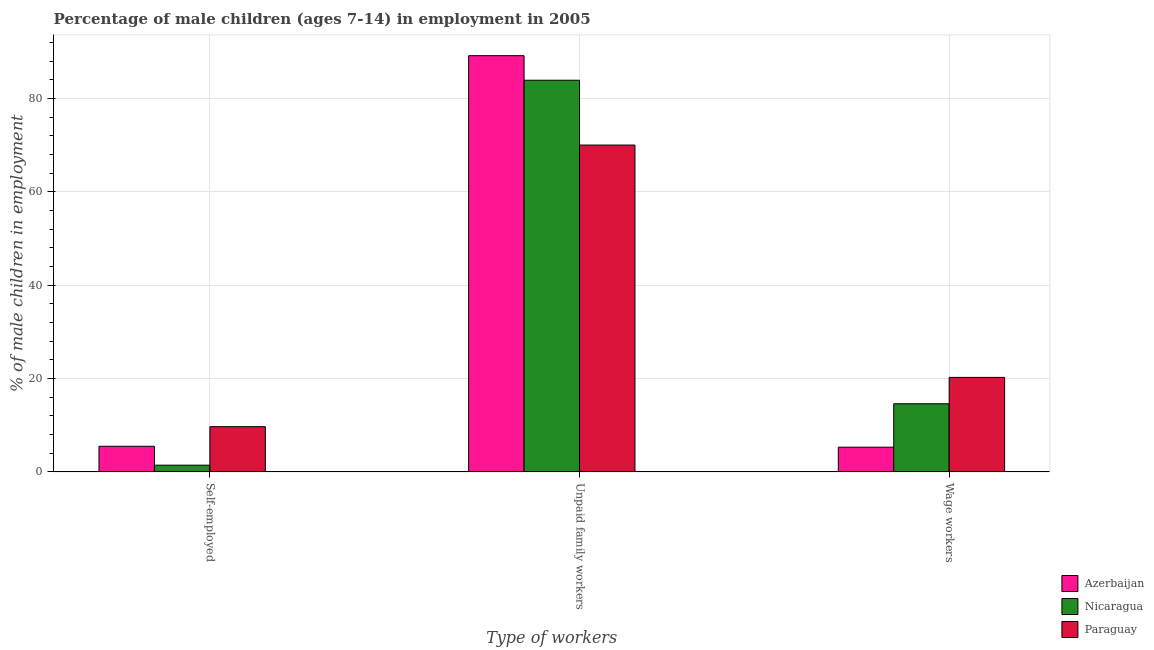How many different coloured bars are there?
Make the answer very short. 3. How many groups of bars are there?
Offer a terse response. 3. Are the number of bars on each tick of the X-axis equal?
Provide a short and direct response. Yes. How many bars are there on the 1st tick from the left?
Offer a very short reply. 3. How many bars are there on the 2nd tick from the right?
Keep it short and to the point. 3. What is the label of the 2nd group of bars from the left?
Ensure brevity in your answer.  Unpaid family workers. What is the percentage of self employed children in Nicaragua?
Provide a succinct answer. 1.45. Across all countries, what is the maximum percentage of children employed as wage workers?
Your answer should be very brief. 20.26. Across all countries, what is the minimum percentage of children employed as unpaid family workers?
Provide a succinct answer. 70.05. In which country was the percentage of children employed as unpaid family workers maximum?
Provide a succinct answer. Azerbaijan. In which country was the percentage of children employed as wage workers minimum?
Keep it short and to the point. Azerbaijan. What is the total percentage of children employed as wage workers in the graph?
Your answer should be compact. 40.17. What is the difference between the percentage of self employed children in Paraguay and that in Nicaragua?
Offer a very short reply. 8.25. What is the difference between the percentage of self employed children in Nicaragua and the percentage of children employed as wage workers in Paraguay?
Keep it short and to the point. -18.81. What is the average percentage of self employed children per country?
Ensure brevity in your answer.  5.55. What is the difference between the percentage of self employed children and percentage of children employed as unpaid family workers in Nicaragua?
Your answer should be very brief. -82.49. In how many countries, is the percentage of children employed as wage workers greater than 48 %?
Your answer should be compact. 0. What is the ratio of the percentage of self employed children in Nicaragua to that in Paraguay?
Provide a short and direct response. 0.15. Is the difference between the percentage of children employed as wage workers in Paraguay and Nicaragua greater than the difference between the percentage of children employed as unpaid family workers in Paraguay and Nicaragua?
Give a very brief answer. Yes. What is the difference between the highest and the second highest percentage of self employed children?
Provide a succinct answer. 4.2. What is the difference between the highest and the lowest percentage of self employed children?
Make the answer very short. 8.25. In how many countries, is the percentage of children employed as unpaid family workers greater than the average percentage of children employed as unpaid family workers taken over all countries?
Give a very brief answer. 2. Is the sum of the percentage of children employed as unpaid family workers in Nicaragua and Paraguay greater than the maximum percentage of children employed as wage workers across all countries?
Make the answer very short. Yes. What does the 2nd bar from the left in Unpaid family workers represents?
Offer a terse response. Nicaragua. What does the 1st bar from the right in Unpaid family workers represents?
Provide a short and direct response. Paraguay. Are all the bars in the graph horizontal?
Ensure brevity in your answer.  No. How many countries are there in the graph?
Ensure brevity in your answer.  3. Are the values on the major ticks of Y-axis written in scientific E-notation?
Your response must be concise. No. Does the graph contain any zero values?
Offer a terse response. No. Does the graph contain grids?
Give a very brief answer. Yes. How are the legend labels stacked?
Your answer should be very brief. Vertical. What is the title of the graph?
Provide a succinct answer. Percentage of male children (ages 7-14) in employment in 2005. What is the label or title of the X-axis?
Your answer should be compact. Type of workers. What is the label or title of the Y-axis?
Offer a very short reply. % of male children in employment. What is the % of male children in employment in Azerbaijan in Self-employed?
Your answer should be compact. 5.5. What is the % of male children in employment of Nicaragua in Self-employed?
Offer a terse response. 1.45. What is the % of male children in employment of Azerbaijan in Unpaid family workers?
Provide a short and direct response. 89.2. What is the % of male children in employment in Nicaragua in Unpaid family workers?
Ensure brevity in your answer.  83.94. What is the % of male children in employment in Paraguay in Unpaid family workers?
Your answer should be compact. 70.05. What is the % of male children in employment of Nicaragua in Wage workers?
Offer a terse response. 14.61. What is the % of male children in employment in Paraguay in Wage workers?
Ensure brevity in your answer.  20.26. Across all Type of workers, what is the maximum % of male children in employment in Azerbaijan?
Make the answer very short. 89.2. Across all Type of workers, what is the maximum % of male children in employment of Nicaragua?
Your answer should be very brief. 83.94. Across all Type of workers, what is the maximum % of male children in employment in Paraguay?
Give a very brief answer. 70.05. Across all Type of workers, what is the minimum % of male children in employment of Nicaragua?
Your answer should be compact. 1.45. Across all Type of workers, what is the minimum % of male children in employment in Paraguay?
Provide a short and direct response. 9.7. What is the total % of male children in employment of Azerbaijan in the graph?
Keep it short and to the point. 100. What is the total % of male children in employment of Nicaragua in the graph?
Make the answer very short. 100. What is the total % of male children in employment in Paraguay in the graph?
Your answer should be compact. 100.01. What is the difference between the % of male children in employment in Azerbaijan in Self-employed and that in Unpaid family workers?
Your answer should be compact. -83.7. What is the difference between the % of male children in employment in Nicaragua in Self-employed and that in Unpaid family workers?
Keep it short and to the point. -82.49. What is the difference between the % of male children in employment of Paraguay in Self-employed and that in Unpaid family workers?
Make the answer very short. -60.35. What is the difference between the % of male children in employment in Nicaragua in Self-employed and that in Wage workers?
Provide a succinct answer. -13.16. What is the difference between the % of male children in employment of Paraguay in Self-employed and that in Wage workers?
Your response must be concise. -10.56. What is the difference between the % of male children in employment of Azerbaijan in Unpaid family workers and that in Wage workers?
Your response must be concise. 83.9. What is the difference between the % of male children in employment of Nicaragua in Unpaid family workers and that in Wage workers?
Offer a very short reply. 69.33. What is the difference between the % of male children in employment of Paraguay in Unpaid family workers and that in Wage workers?
Your response must be concise. 49.79. What is the difference between the % of male children in employment in Azerbaijan in Self-employed and the % of male children in employment in Nicaragua in Unpaid family workers?
Provide a short and direct response. -78.44. What is the difference between the % of male children in employment in Azerbaijan in Self-employed and the % of male children in employment in Paraguay in Unpaid family workers?
Ensure brevity in your answer.  -64.55. What is the difference between the % of male children in employment of Nicaragua in Self-employed and the % of male children in employment of Paraguay in Unpaid family workers?
Provide a short and direct response. -68.6. What is the difference between the % of male children in employment of Azerbaijan in Self-employed and the % of male children in employment of Nicaragua in Wage workers?
Your answer should be very brief. -9.11. What is the difference between the % of male children in employment of Azerbaijan in Self-employed and the % of male children in employment of Paraguay in Wage workers?
Give a very brief answer. -14.76. What is the difference between the % of male children in employment in Nicaragua in Self-employed and the % of male children in employment in Paraguay in Wage workers?
Ensure brevity in your answer.  -18.81. What is the difference between the % of male children in employment of Azerbaijan in Unpaid family workers and the % of male children in employment of Nicaragua in Wage workers?
Provide a succinct answer. 74.59. What is the difference between the % of male children in employment of Azerbaijan in Unpaid family workers and the % of male children in employment of Paraguay in Wage workers?
Provide a short and direct response. 68.94. What is the difference between the % of male children in employment of Nicaragua in Unpaid family workers and the % of male children in employment of Paraguay in Wage workers?
Ensure brevity in your answer.  63.68. What is the average % of male children in employment in Azerbaijan per Type of workers?
Your answer should be compact. 33.33. What is the average % of male children in employment of Nicaragua per Type of workers?
Make the answer very short. 33.33. What is the average % of male children in employment in Paraguay per Type of workers?
Give a very brief answer. 33.34. What is the difference between the % of male children in employment in Azerbaijan and % of male children in employment in Nicaragua in Self-employed?
Offer a terse response. 4.05. What is the difference between the % of male children in employment in Nicaragua and % of male children in employment in Paraguay in Self-employed?
Provide a succinct answer. -8.25. What is the difference between the % of male children in employment in Azerbaijan and % of male children in employment in Nicaragua in Unpaid family workers?
Provide a short and direct response. 5.26. What is the difference between the % of male children in employment in Azerbaijan and % of male children in employment in Paraguay in Unpaid family workers?
Your response must be concise. 19.15. What is the difference between the % of male children in employment of Nicaragua and % of male children in employment of Paraguay in Unpaid family workers?
Provide a succinct answer. 13.89. What is the difference between the % of male children in employment in Azerbaijan and % of male children in employment in Nicaragua in Wage workers?
Give a very brief answer. -9.31. What is the difference between the % of male children in employment in Azerbaijan and % of male children in employment in Paraguay in Wage workers?
Offer a very short reply. -14.96. What is the difference between the % of male children in employment of Nicaragua and % of male children in employment of Paraguay in Wage workers?
Offer a terse response. -5.65. What is the ratio of the % of male children in employment of Azerbaijan in Self-employed to that in Unpaid family workers?
Give a very brief answer. 0.06. What is the ratio of the % of male children in employment of Nicaragua in Self-employed to that in Unpaid family workers?
Your answer should be compact. 0.02. What is the ratio of the % of male children in employment of Paraguay in Self-employed to that in Unpaid family workers?
Keep it short and to the point. 0.14. What is the ratio of the % of male children in employment in Azerbaijan in Self-employed to that in Wage workers?
Ensure brevity in your answer.  1.04. What is the ratio of the % of male children in employment of Nicaragua in Self-employed to that in Wage workers?
Provide a short and direct response. 0.1. What is the ratio of the % of male children in employment in Paraguay in Self-employed to that in Wage workers?
Your response must be concise. 0.48. What is the ratio of the % of male children in employment in Azerbaijan in Unpaid family workers to that in Wage workers?
Give a very brief answer. 16.83. What is the ratio of the % of male children in employment of Nicaragua in Unpaid family workers to that in Wage workers?
Your response must be concise. 5.75. What is the ratio of the % of male children in employment of Paraguay in Unpaid family workers to that in Wage workers?
Give a very brief answer. 3.46. What is the difference between the highest and the second highest % of male children in employment of Azerbaijan?
Make the answer very short. 83.7. What is the difference between the highest and the second highest % of male children in employment of Nicaragua?
Keep it short and to the point. 69.33. What is the difference between the highest and the second highest % of male children in employment in Paraguay?
Your answer should be very brief. 49.79. What is the difference between the highest and the lowest % of male children in employment in Azerbaijan?
Keep it short and to the point. 83.9. What is the difference between the highest and the lowest % of male children in employment in Nicaragua?
Keep it short and to the point. 82.49. What is the difference between the highest and the lowest % of male children in employment in Paraguay?
Offer a very short reply. 60.35. 